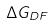<formula> <loc_0><loc_0><loc_500><loc_500>\Delta G _ { D F }</formula> 